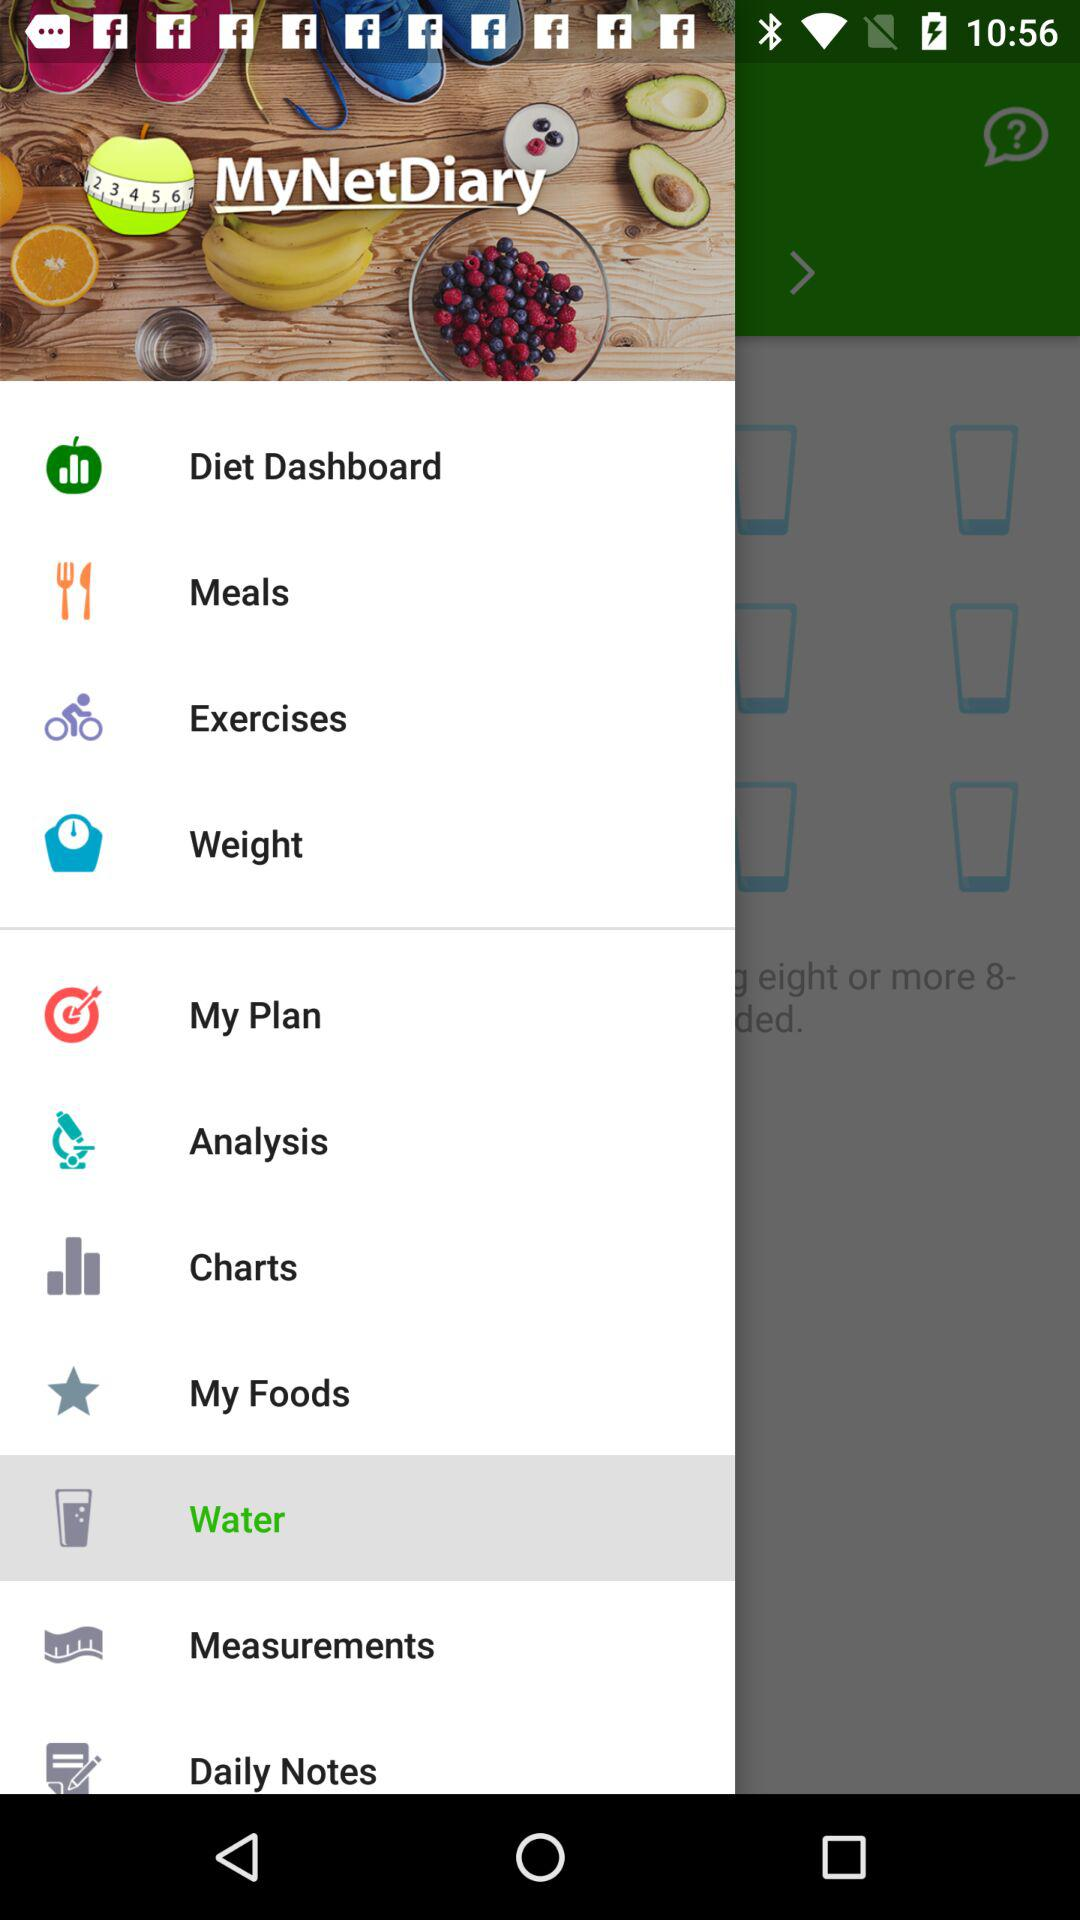What is the selected category? The selected category is water. 